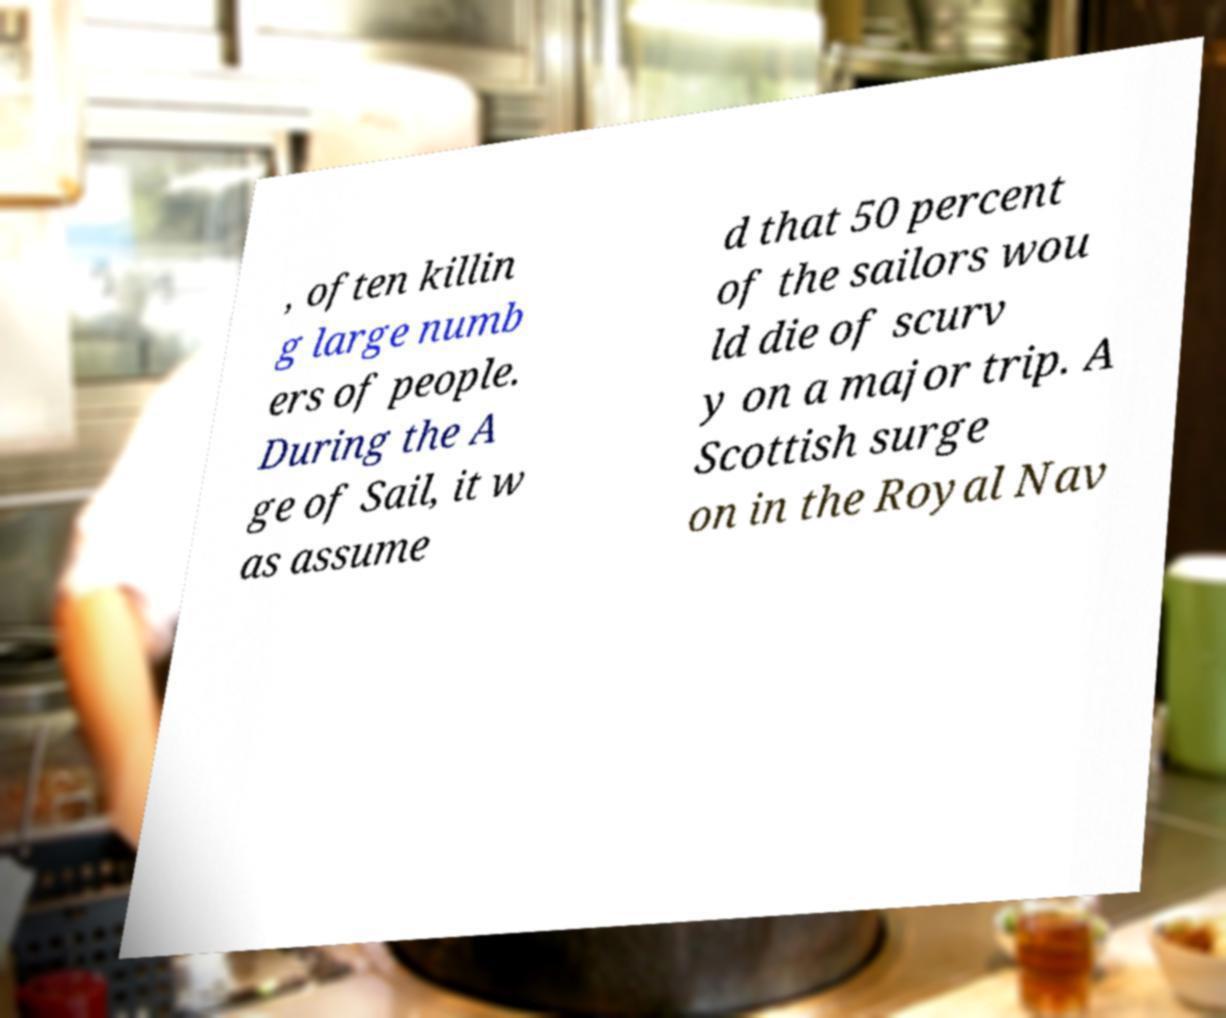Please identify and transcribe the text found in this image. , often killin g large numb ers of people. During the A ge of Sail, it w as assume d that 50 percent of the sailors wou ld die of scurv y on a major trip. A Scottish surge on in the Royal Nav 